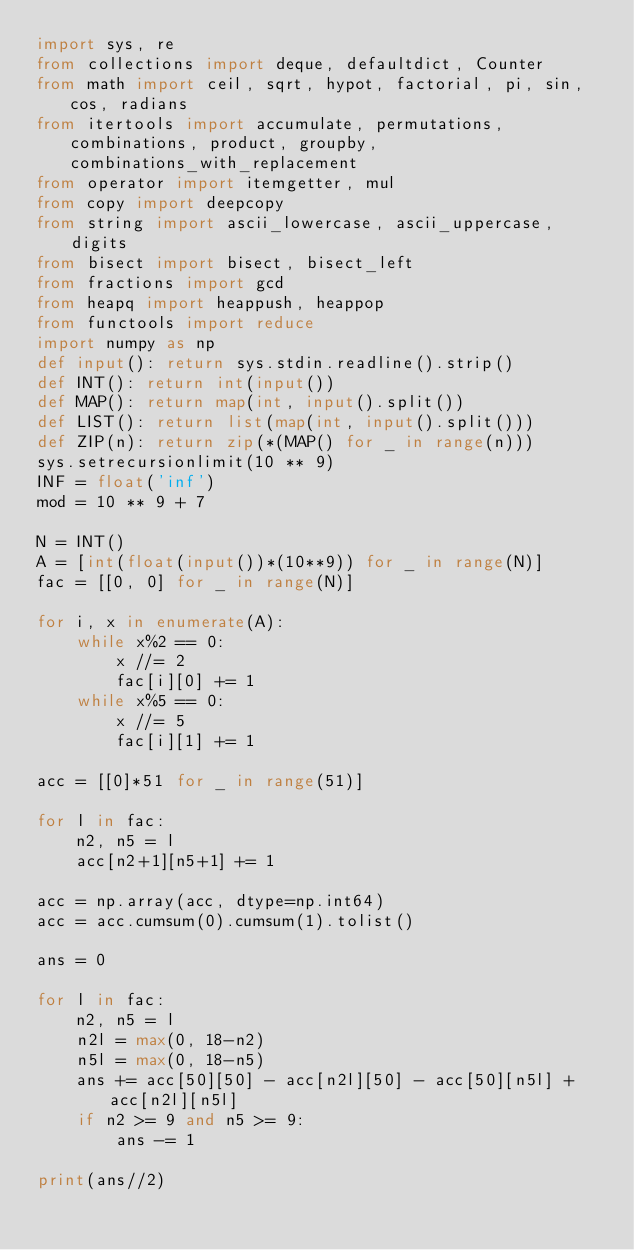<code> <loc_0><loc_0><loc_500><loc_500><_Python_>import sys, re
from collections import deque, defaultdict, Counter
from math import ceil, sqrt, hypot, factorial, pi, sin, cos, radians
from itertools import accumulate, permutations, combinations, product, groupby, combinations_with_replacement
from operator import itemgetter, mul
from copy import deepcopy
from string import ascii_lowercase, ascii_uppercase, digits
from bisect import bisect, bisect_left
from fractions import gcd
from heapq import heappush, heappop
from functools import reduce
import numpy as np
def input(): return sys.stdin.readline().strip()
def INT(): return int(input())
def MAP(): return map(int, input().split())
def LIST(): return list(map(int, input().split()))
def ZIP(n): return zip(*(MAP() for _ in range(n)))
sys.setrecursionlimit(10 ** 9)
INF = float('inf')
mod = 10 ** 9 + 7

N = INT()
A = [int(float(input())*(10**9)) for _ in range(N)]
fac = [[0, 0] for _ in range(N)]

for i, x in enumerate(A):
    while x%2 == 0:
        x //= 2
        fac[i][0] += 1
    while x%5 == 0:
        x //= 5
        fac[i][1] += 1

acc = [[0]*51 for _ in range(51)]

for l in fac:
    n2, n5 = l
    acc[n2+1][n5+1] += 1

acc = np.array(acc, dtype=np.int64)
acc = acc.cumsum(0).cumsum(1).tolist()

ans = 0

for l in fac:
    n2, n5 = l
    n2l = max(0, 18-n2)
    n5l = max(0, 18-n5)
    ans += acc[50][50] - acc[n2l][50] - acc[50][n5l] + acc[n2l][n5l]
    if n2 >= 9 and n5 >= 9:
        ans -= 1

print(ans//2)
</code> 